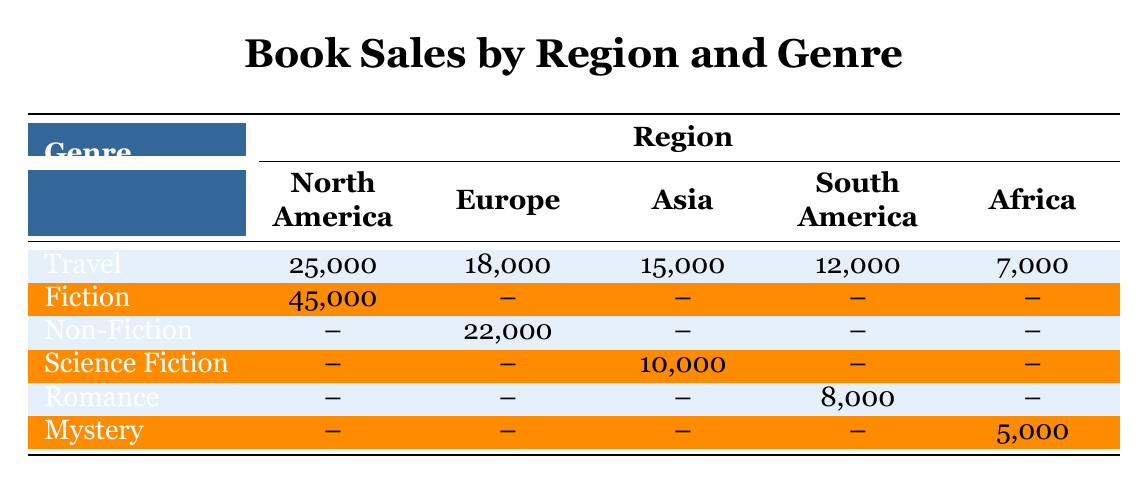What is the total sales for the Travel genre in North America? The sales for the Travel genre in North America is given in the table as 25,000.
Answer: 25,000 Which region has the highest sales for Fiction books? The table shows that North America has a sales figure for Fiction of 45,000, while all other regions have no sales for this genre. Therefore, North America has the highest sales for Fiction.
Answer: North America Are there any sales recorded for Romance books in Europe? According to the table, there are no sales for Romance books listed under Europe, as the corresponding cell shows a dash (--) which indicates no sales.
Answer: No What is the combined sales for Travel books across all regions? To calculate the combined sales for Travel books, we sum the sales from all regions: North America (25,000) + Europe (18,000) + Asia (15,000) + South America (12,000) + Africa (7,000), which equals 77,000.
Answer: 77,000 Is there any genre with sales in all regions? Looking at the table, no genre has sales recorded in all regions. Travel is the only genre with sales in multiple regions, but not all. Thus, the answer is no.
Answer: No What is the average sales for Non-Fiction books across the regions where it is sold? Non-Fiction books are sold only in Europe with sales of 22,000. Since there is only one sales figure, the average is the same as the sales amount, which is 22,000.
Answer: 22,000 What is the difference in sales between the highest and lowest sales in the Travel genre? The highest sales for Travel is in North America with 25,000, and the lowest is in Africa with 7,000. The difference is 25,000 - 7,000 = 18,000.
Answer: 18,000 How many genres show sales in South America? From the table, we see that there are two genres with recorded sales in South America: Travel (12,000) and Romance (8,000). Therefore, the count of genres is 2.
Answer: 2 Which region has sales for Science Fiction books? The table indicates that Asia has sales for Science Fiction books with a figure of 10,000. No other regions have recorded sales for this genre.
Answer: Asia 